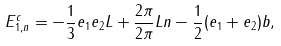Convert formula to latex. <formula><loc_0><loc_0><loc_500><loc_500>E _ { 1 , n } ^ { c } = - \frac { 1 } { 3 } e _ { 1 } e _ { 2 } L + \frac { 2 \pi } { 2 \pi } L n - \frac { 1 } { 2 } ( e _ { 1 } + e _ { 2 } ) b ,</formula> 